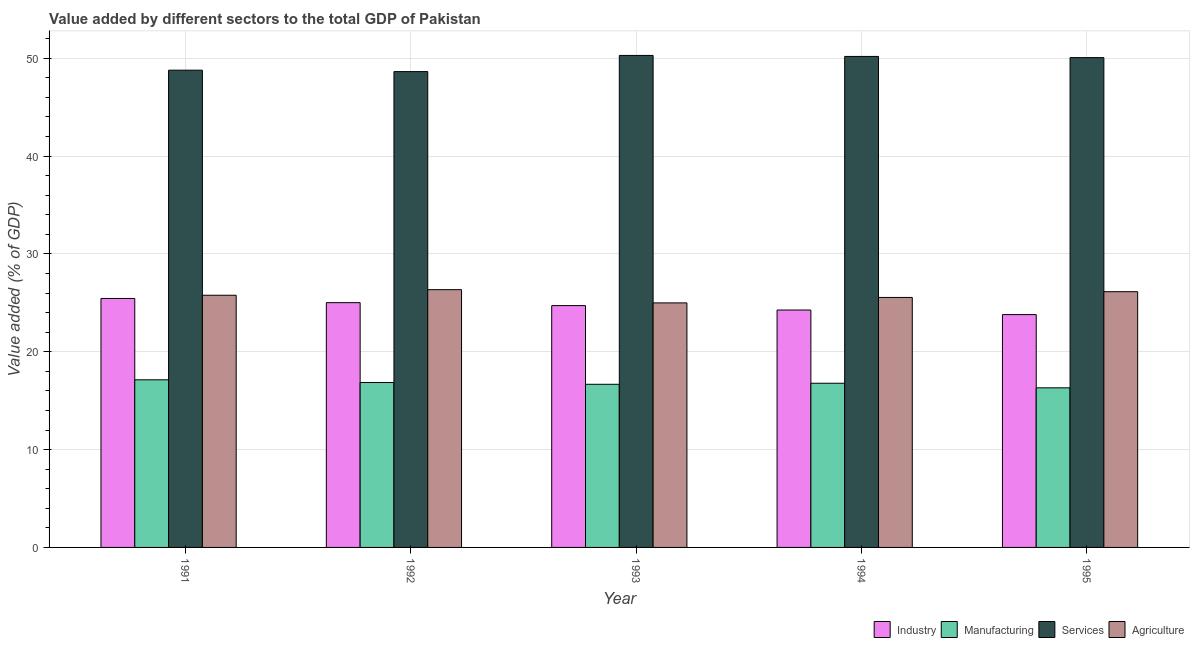How many different coloured bars are there?
Keep it short and to the point. 4. Are the number of bars per tick equal to the number of legend labels?
Provide a short and direct response. Yes. How many bars are there on the 2nd tick from the left?
Ensure brevity in your answer.  4. What is the value added by manufacturing sector in 1992?
Offer a very short reply. 16.86. Across all years, what is the maximum value added by services sector?
Offer a very short reply. 50.29. Across all years, what is the minimum value added by agricultural sector?
Your response must be concise. 24.99. In which year was the value added by industrial sector maximum?
Your answer should be very brief. 1991. In which year was the value added by services sector minimum?
Offer a very short reply. 1992. What is the total value added by services sector in the graph?
Make the answer very short. 247.95. What is the difference between the value added by agricultural sector in 1993 and that in 1994?
Offer a very short reply. -0.56. What is the difference between the value added by services sector in 1992 and the value added by industrial sector in 1993?
Make the answer very short. -1.65. What is the average value added by industrial sector per year?
Provide a short and direct response. 24.65. In the year 1991, what is the difference between the value added by services sector and value added by agricultural sector?
Make the answer very short. 0. What is the ratio of the value added by industrial sector in 1992 to that in 1994?
Provide a short and direct response. 1.03. Is the value added by agricultural sector in 1991 less than that in 1995?
Make the answer very short. Yes. Is the difference between the value added by agricultural sector in 1992 and 1994 greater than the difference between the value added by industrial sector in 1992 and 1994?
Make the answer very short. No. What is the difference between the highest and the second highest value added by agricultural sector?
Make the answer very short. 0.21. What is the difference between the highest and the lowest value added by manufacturing sector?
Provide a succinct answer. 0.82. In how many years, is the value added by services sector greater than the average value added by services sector taken over all years?
Provide a succinct answer. 3. Is it the case that in every year, the sum of the value added by agricultural sector and value added by services sector is greater than the sum of value added by industrial sector and value added by manufacturing sector?
Provide a short and direct response. No. What does the 4th bar from the left in 1992 represents?
Your answer should be compact. Agriculture. What does the 2nd bar from the right in 1991 represents?
Your response must be concise. Services. Is it the case that in every year, the sum of the value added by industrial sector and value added by manufacturing sector is greater than the value added by services sector?
Give a very brief answer. No. Are all the bars in the graph horizontal?
Your answer should be very brief. No. How many years are there in the graph?
Provide a short and direct response. 5. Does the graph contain any zero values?
Provide a short and direct response. No. Where does the legend appear in the graph?
Ensure brevity in your answer.  Bottom right. What is the title of the graph?
Provide a short and direct response. Value added by different sectors to the total GDP of Pakistan. What is the label or title of the Y-axis?
Provide a short and direct response. Value added (% of GDP). What is the Value added (% of GDP) in Industry in 1991?
Keep it short and to the point. 25.45. What is the Value added (% of GDP) in Manufacturing in 1991?
Make the answer very short. 17.13. What is the Value added (% of GDP) of Services in 1991?
Offer a terse response. 48.78. What is the Value added (% of GDP) of Agriculture in 1991?
Keep it short and to the point. 25.77. What is the Value added (% of GDP) of Industry in 1992?
Provide a succinct answer. 25.02. What is the Value added (% of GDP) in Manufacturing in 1992?
Offer a very short reply. 16.86. What is the Value added (% of GDP) in Services in 1992?
Offer a terse response. 48.63. What is the Value added (% of GDP) of Agriculture in 1992?
Your response must be concise. 26.35. What is the Value added (% of GDP) in Industry in 1993?
Offer a very short reply. 24.72. What is the Value added (% of GDP) of Manufacturing in 1993?
Make the answer very short. 16.67. What is the Value added (% of GDP) in Services in 1993?
Give a very brief answer. 50.29. What is the Value added (% of GDP) of Agriculture in 1993?
Offer a very short reply. 24.99. What is the Value added (% of GDP) in Industry in 1994?
Your response must be concise. 24.26. What is the Value added (% of GDP) in Manufacturing in 1994?
Keep it short and to the point. 16.78. What is the Value added (% of GDP) in Services in 1994?
Give a very brief answer. 50.19. What is the Value added (% of GDP) in Agriculture in 1994?
Offer a very short reply. 25.55. What is the Value added (% of GDP) of Industry in 1995?
Your answer should be compact. 23.8. What is the Value added (% of GDP) of Manufacturing in 1995?
Make the answer very short. 16.31. What is the Value added (% of GDP) of Services in 1995?
Offer a terse response. 50.06. What is the Value added (% of GDP) of Agriculture in 1995?
Provide a short and direct response. 26.14. Across all years, what is the maximum Value added (% of GDP) in Industry?
Provide a succinct answer. 25.45. Across all years, what is the maximum Value added (% of GDP) in Manufacturing?
Make the answer very short. 17.13. Across all years, what is the maximum Value added (% of GDP) in Services?
Keep it short and to the point. 50.29. Across all years, what is the maximum Value added (% of GDP) of Agriculture?
Offer a terse response. 26.35. Across all years, what is the minimum Value added (% of GDP) of Industry?
Make the answer very short. 23.8. Across all years, what is the minimum Value added (% of GDP) in Manufacturing?
Ensure brevity in your answer.  16.31. Across all years, what is the minimum Value added (% of GDP) of Services?
Make the answer very short. 48.63. Across all years, what is the minimum Value added (% of GDP) in Agriculture?
Your response must be concise. 24.99. What is the total Value added (% of GDP) of Industry in the graph?
Keep it short and to the point. 123.24. What is the total Value added (% of GDP) in Manufacturing in the graph?
Give a very brief answer. 83.76. What is the total Value added (% of GDP) in Services in the graph?
Keep it short and to the point. 247.95. What is the total Value added (% of GDP) of Agriculture in the graph?
Make the answer very short. 128.8. What is the difference between the Value added (% of GDP) of Industry in 1991 and that in 1992?
Your answer should be compact. 0.43. What is the difference between the Value added (% of GDP) of Manufacturing in 1991 and that in 1992?
Provide a short and direct response. 0.28. What is the difference between the Value added (% of GDP) of Services in 1991 and that in 1992?
Your answer should be compact. 0.14. What is the difference between the Value added (% of GDP) of Agriculture in 1991 and that in 1992?
Keep it short and to the point. -0.57. What is the difference between the Value added (% of GDP) in Industry in 1991 and that in 1993?
Give a very brief answer. 0.73. What is the difference between the Value added (% of GDP) in Manufacturing in 1991 and that in 1993?
Your response must be concise. 0.46. What is the difference between the Value added (% of GDP) in Services in 1991 and that in 1993?
Your answer should be very brief. -1.51. What is the difference between the Value added (% of GDP) of Agriculture in 1991 and that in 1993?
Offer a terse response. 0.78. What is the difference between the Value added (% of GDP) in Industry in 1991 and that in 1994?
Your answer should be compact. 1.18. What is the difference between the Value added (% of GDP) in Manufacturing in 1991 and that in 1994?
Your answer should be compact. 0.35. What is the difference between the Value added (% of GDP) in Services in 1991 and that in 1994?
Your answer should be compact. -1.41. What is the difference between the Value added (% of GDP) in Agriculture in 1991 and that in 1994?
Provide a succinct answer. 0.22. What is the difference between the Value added (% of GDP) of Industry in 1991 and that in 1995?
Provide a succinct answer. 1.65. What is the difference between the Value added (% of GDP) of Manufacturing in 1991 and that in 1995?
Your response must be concise. 0.82. What is the difference between the Value added (% of GDP) of Services in 1991 and that in 1995?
Make the answer very short. -1.28. What is the difference between the Value added (% of GDP) of Agriculture in 1991 and that in 1995?
Provide a succinct answer. -0.36. What is the difference between the Value added (% of GDP) in Industry in 1992 and that in 1993?
Your answer should be compact. 0.3. What is the difference between the Value added (% of GDP) in Manufacturing in 1992 and that in 1993?
Provide a succinct answer. 0.18. What is the difference between the Value added (% of GDP) of Services in 1992 and that in 1993?
Keep it short and to the point. -1.65. What is the difference between the Value added (% of GDP) in Agriculture in 1992 and that in 1993?
Your response must be concise. 1.35. What is the difference between the Value added (% of GDP) of Industry in 1992 and that in 1994?
Provide a short and direct response. 0.75. What is the difference between the Value added (% of GDP) of Manufacturing in 1992 and that in 1994?
Ensure brevity in your answer.  0.07. What is the difference between the Value added (% of GDP) in Services in 1992 and that in 1994?
Provide a succinct answer. -1.55. What is the difference between the Value added (% of GDP) of Agriculture in 1992 and that in 1994?
Make the answer very short. 0.8. What is the difference between the Value added (% of GDP) of Industry in 1992 and that in 1995?
Keep it short and to the point. 1.22. What is the difference between the Value added (% of GDP) in Manufacturing in 1992 and that in 1995?
Keep it short and to the point. 0.54. What is the difference between the Value added (% of GDP) in Services in 1992 and that in 1995?
Offer a very short reply. -1.43. What is the difference between the Value added (% of GDP) in Agriculture in 1992 and that in 1995?
Ensure brevity in your answer.  0.21. What is the difference between the Value added (% of GDP) in Industry in 1993 and that in 1994?
Provide a short and direct response. 0.45. What is the difference between the Value added (% of GDP) in Manufacturing in 1993 and that in 1994?
Keep it short and to the point. -0.11. What is the difference between the Value added (% of GDP) in Services in 1993 and that in 1994?
Provide a succinct answer. 0.1. What is the difference between the Value added (% of GDP) of Agriculture in 1993 and that in 1994?
Your answer should be very brief. -0.56. What is the difference between the Value added (% of GDP) of Industry in 1993 and that in 1995?
Ensure brevity in your answer.  0.92. What is the difference between the Value added (% of GDP) of Manufacturing in 1993 and that in 1995?
Offer a terse response. 0.36. What is the difference between the Value added (% of GDP) in Services in 1993 and that in 1995?
Make the answer very short. 0.22. What is the difference between the Value added (% of GDP) in Agriculture in 1993 and that in 1995?
Your response must be concise. -1.14. What is the difference between the Value added (% of GDP) of Industry in 1994 and that in 1995?
Offer a very short reply. 0.47. What is the difference between the Value added (% of GDP) in Manufacturing in 1994 and that in 1995?
Give a very brief answer. 0.47. What is the difference between the Value added (% of GDP) of Services in 1994 and that in 1995?
Provide a succinct answer. 0.12. What is the difference between the Value added (% of GDP) in Agriculture in 1994 and that in 1995?
Make the answer very short. -0.59. What is the difference between the Value added (% of GDP) of Industry in 1991 and the Value added (% of GDP) of Manufacturing in 1992?
Your answer should be very brief. 8.59. What is the difference between the Value added (% of GDP) of Industry in 1991 and the Value added (% of GDP) of Services in 1992?
Keep it short and to the point. -23.19. What is the difference between the Value added (% of GDP) in Industry in 1991 and the Value added (% of GDP) in Agriculture in 1992?
Give a very brief answer. -0.9. What is the difference between the Value added (% of GDP) in Manufacturing in 1991 and the Value added (% of GDP) in Services in 1992?
Offer a very short reply. -31.5. What is the difference between the Value added (% of GDP) of Manufacturing in 1991 and the Value added (% of GDP) of Agriculture in 1992?
Offer a very short reply. -9.21. What is the difference between the Value added (% of GDP) in Services in 1991 and the Value added (% of GDP) in Agriculture in 1992?
Your answer should be compact. 22.43. What is the difference between the Value added (% of GDP) of Industry in 1991 and the Value added (% of GDP) of Manufacturing in 1993?
Offer a terse response. 8.77. What is the difference between the Value added (% of GDP) of Industry in 1991 and the Value added (% of GDP) of Services in 1993?
Your answer should be compact. -24.84. What is the difference between the Value added (% of GDP) in Industry in 1991 and the Value added (% of GDP) in Agriculture in 1993?
Keep it short and to the point. 0.45. What is the difference between the Value added (% of GDP) of Manufacturing in 1991 and the Value added (% of GDP) of Services in 1993?
Offer a terse response. -33.16. What is the difference between the Value added (% of GDP) in Manufacturing in 1991 and the Value added (% of GDP) in Agriculture in 1993?
Your response must be concise. -7.86. What is the difference between the Value added (% of GDP) in Services in 1991 and the Value added (% of GDP) in Agriculture in 1993?
Make the answer very short. 23.79. What is the difference between the Value added (% of GDP) of Industry in 1991 and the Value added (% of GDP) of Manufacturing in 1994?
Offer a terse response. 8.66. What is the difference between the Value added (% of GDP) of Industry in 1991 and the Value added (% of GDP) of Services in 1994?
Make the answer very short. -24.74. What is the difference between the Value added (% of GDP) in Industry in 1991 and the Value added (% of GDP) in Agriculture in 1994?
Keep it short and to the point. -0.1. What is the difference between the Value added (% of GDP) of Manufacturing in 1991 and the Value added (% of GDP) of Services in 1994?
Keep it short and to the point. -33.05. What is the difference between the Value added (% of GDP) in Manufacturing in 1991 and the Value added (% of GDP) in Agriculture in 1994?
Make the answer very short. -8.42. What is the difference between the Value added (% of GDP) in Services in 1991 and the Value added (% of GDP) in Agriculture in 1994?
Make the answer very short. 23.23. What is the difference between the Value added (% of GDP) in Industry in 1991 and the Value added (% of GDP) in Manufacturing in 1995?
Offer a terse response. 9.13. What is the difference between the Value added (% of GDP) of Industry in 1991 and the Value added (% of GDP) of Services in 1995?
Give a very brief answer. -24.62. What is the difference between the Value added (% of GDP) of Industry in 1991 and the Value added (% of GDP) of Agriculture in 1995?
Provide a succinct answer. -0.69. What is the difference between the Value added (% of GDP) of Manufacturing in 1991 and the Value added (% of GDP) of Services in 1995?
Your answer should be very brief. -32.93. What is the difference between the Value added (% of GDP) in Manufacturing in 1991 and the Value added (% of GDP) in Agriculture in 1995?
Your response must be concise. -9.01. What is the difference between the Value added (% of GDP) of Services in 1991 and the Value added (% of GDP) of Agriculture in 1995?
Your answer should be compact. 22.64. What is the difference between the Value added (% of GDP) in Industry in 1992 and the Value added (% of GDP) in Manufacturing in 1993?
Make the answer very short. 8.34. What is the difference between the Value added (% of GDP) in Industry in 1992 and the Value added (% of GDP) in Services in 1993?
Offer a very short reply. -25.27. What is the difference between the Value added (% of GDP) of Industry in 1992 and the Value added (% of GDP) of Agriculture in 1993?
Make the answer very short. 0.02. What is the difference between the Value added (% of GDP) in Manufacturing in 1992 and the Value added (% of GDP) in Services in 1993?
Make the answer very short. -33.43. What is the difference between the Value added (% of GDP) of Manufacturing in 1992 and the Value added (% of GDP) of Agriculture in 1993?
Your response must be concise. -8.14. What is the difference between the Value added (% of GDP) of Services in 1992 and the Value added (% of GDP) of Agriculture in 1993?
Provide a succinct answer. 23.64. What is the difference between the Value added (% of GDP) in Industry in 1992 and the Value added (% of GDP) in Manufacturing in 1994?
Your response must be concise. 8.24. What is the difference between the Value added (% of GDP) in Industry in 1992 and the Value added (% of GDP) in Services in 1994?
Make the answer very short. -25.17. What is the difference between the Value added (% of GDP) in Industry in 1992 and the Value added (% of GDP) in Agriculture in 1994?
Provide a succinct answer. -0.53. What is the difference between the Value added (% of GDP) of Manufacturing in 1992 and the Value added (% of GDP) of Services in 1994?
Provide a succinct answer. -33.33. What is the difference between the Value added (% of GDP) in Manufacturing in 1992 and the Value added (% of GDP) in Agriculture in 1994?
Your answer should be very brief. -8.69. What is the difference between the Value added (% of GDP) of Services in 1992 and the Value added (% of GDP) of Agriculture in 1994?
Your answer should be very brief. 23.08. What is the difference between the Value added (% of GDP) of Industry in 1992 and the Value added (% of GDP) of Manufacturing in 1995?
Provide a succinct answer. 8.7. What is the difference between the Value added (% of GDP) in Industry in 1992 and the Value added (% of GDP) in Services in 1995?
Provide a short and direct response. -25.05. What is the difference between the Value added (% of GDP) of Industry in 1992 and the Value added (% of GDP) of Agriculture in 1995?
Your answer should be very brief. -1.12. What is the difference between the Value added (% of GDP) in Manufacturing in 1992 and the Value added (% of GDP) in Services in 1995?
Give a very brief answer. -33.21. What is the difference between the Value added (% of GDP) of Manufacturing in 1992 and the Value added (% of GDP) of Agriculture in 1995?
Provide a succinct answer. -9.28. What is the difference between the Value added (% of GDP) of Services in 1992 and the Value added (% of GDP) of Agriculture in 1995?
Your answer should be compact. 22.5. What is the difference between the Value added (% of GDP) of Industry in 1993 and the Value added (% of GDP) of Manufacturing in 1994?
Your response must be concise. 7.94. What is the difference between the Value added (% of GDP) of Industry in 1993 and the Value added (% of GDP) of Services in 1994?
Offer a very short reply. -25.47. What is the difference between the Value added (% of GDP) in Industry in 1993 and the Value added (% of GDP) in Agriculture in 1994?
Give a very brief answer. -0.83. What is the difference between the Value added (% of GDP) of Manufacturing in 1993 and the Value added (% of GDP) of Services in 1994?
Ensure brevity in your answer.  -33.51. What is the difference between the Value added (% of GDP) of Manufacturing in 1993 and the Value added (% of GDP) of Agriculture in 1994?
Ensure brevity in your answer.  -8.88. What is the difference between the Value added (% of GDP) in Services in 1993 and the Value added (% of GDP) in Agriculture in 1994?
Your answer should be very brief. 24.74. What is the difference between the Value added (% of GDP) in Industry in 1993 and the Value added (% of GDP) in Manufacturing in 1995?
Give a very brief answer. 8.4. What is the difference between the Value added (% of GDP) of Industry in 1993 and the Value added (% of GDP) of Services in 1995?
Provide a short and direct response. -25.35. What is the difference between the Value added (% of GDP) of Industry in 1993 and the Value added (% of GDP) of Agriculture in 1995?
Offer a terse response. -1.42. What is the difference between the Value added (% of GDP) of Manufacturing in 1993 and the Value added (% of GDP) of Services in 1995?
Ensure brevity in your answer.  -33.39. What is the difference between the Value added (% of GDP) in Manufacturing in 1993 and the Value added (% of GDP) in Agriculture in 1995?
Your answer should be compact. -9.46. What is the difference between the Value added (% of GDP) in Services in 1993 and the Value added (% of GDP) in Agriculture in 1995?
Your response must be concise. 24.15. What is the difference between the Value added (% of GDP) in Industry in 1994 and the Value added (% of GDP) in Manufacturing in 1995?
Your answer should be compact. 7.95. What is the difference between the Value added (% of GDP) in Industry in 1994 and the Value added (% of GDP) in Services in 1995?
Provide a succinct answer. -25.8. What is the difference between the Value added (% of GDP) in Industry in 1994 and the Value added (% of GDP) in Agriculture in 1995?
Offer a terse response. -1.87. What is the difference between the Value added (% of GDP) in Manufacturing in 1994 and the Value added (% of GDP) in Services in 1995?
Offer a terse response. -33.28. What is the difference between the Value added (% of GDP) in Manufacturing in 1994 and the Value added (% of GDP) in Agriculture in 1995?
Offer a very short reply. -9.36. What is the difference between the Value added (% of GDP) in Services in 1994 and the Value added (% of GDP) in Agriculture in 1995?
Keep it short and to the point. 24.05. What is the average Value added (% of GDP) of Industry per year?
Provide a succinct answer. 24.65. What is the average Value added (% of GDP) of Manufacturing per year?
Ensure brevity in your answer.  16.75. What is the average Value added (% of GDP) of Services per year?
Offer a very short reply. 49.59. What is the average Value added (% of GDP) of Agriculture per year?
Your answer should be very brief. 25.76. In the year 1991, what is the difference between the Value added (% of GDP) of Industry and Value added (% of GDP) of Manufacturing?
Your response must be concise. 8.31. In the year 1991, what is the difference between the Value added (% of GDP) of Industry and Value added (% of GDP) of Services?
Keep it short and to the point. -23.33. In the year 1991, what is the difference between the Value added (% of GDP) in Industry and Value added (% of GDP) in Agriculture?
Give a very brief answer. -0.33. In the year 1991, what is the difference between the Value added (% of GDP) of Manufacturing and Value added (% of GDP) of Services?
Your response must be concise. -31.65. In the year 1991, what is the difference between the Value added (% of GDP) in Manufacturing and Value added (% of GDP) in Agriculture?
Provide a short and direct response. -8.64. In the year 1991, what is the difference between the Value added (% of GDP) of Services and Value added (% of GDP) of Agriculture?
Your answer should be compact. 23.01. In the year 1992, what is the difference between the Value added (% of GDP) in Industry and Value added (% of GDP) in Manufacturing?
Keep it short and to the point. 8.16. In the year 1992, what is the difference between the Value added (% of GDP) in Industry and Value added (% of GDP) in Services?
Give a very brief answer. -23.62. In the year 1992, what is the difference between the Value added (% of GDP) of Industry and Value added (% of GDP) of Agriculture?
Provide a short and direct response. -1.33. In the year 1992, what is the difference between the Value added (% of GDP) of Manufacturing and Value added (% of GDP) of Services?
Your response must be concise. -31.78. In the year 1992, what is the difference between the Value added (% of GDP) of Manufacturing and Value added (% of GDP) of Agriculture?
Ensure brevity in your answer.  -9.49. In the year 1992, what is the difference between the Value added (% of GDP) in Services and Value added (% of GDP) in Agriculture?
Keep it short and to the point. 22.29. In the year 1993, what is the difference between the Value added (% of GDP) of Industry and Value added (% of GDP) of Manufacturing?
Make the answer very short. 8.04. In the year 1993, what is the difference between the Value added (% of GDP) of Industry and Value added (% of GDP) of Services?
Provide a short and direct response. -25.57. In the year 1993, what is the difference between the Value added (% of GDP) of Industry and Value added (% of GDP) of Agriculture?
Your response must be concise. -0.28. In the year 1993, what is the difference between the Value added (% of GDP) in Manufacturing and Value added (% of GDP) in Services?
Provide a succinct answer. -33.61. In the year 1993, what is the difference between the Value added (% of GDP) in Manufacturing and Value added (% of GDP) in Agriculture?
Offer a terse response. -8.32. In the year 1993, what is the difference between the Value added (% of GDP) of Services and Value added (% of GDP) of Agriculture?
Your response must be concise. 25.29. In the year 1994, what is the difference between the Value added (% of GDP) in Industry and Value added (% of GDP) in Manufacturing?
Provide a succinct answer. 7.48. In the year 1994, what is the difference between the Value added (% of GDP) of Industry and Value added (% of GDP) of Services?
Give a very brief answer. -25.92. In the year 1994, what is the difference between the Value added (% of GDP) of Industry and Value added (% of GDP) of Agriculture?
Ensure brevity in your answer.  -1.29. In the year 1994, what is the difference between the Value added (% of GDP) in Manufacturing and Value added (% of GDP) in Services?
Ensure brevity in your answer.  -33.4. In the year 1994, what is the difference between the Value added (% of GDP) in Manufacturing and Value added (% of GDP) in Agriculture?
Offer a very short reply. -8.77. In the year 1994, what is the difference between the Value added (% of GDP) of Services and Value added (% of GDP) of Agriculture?
Make the answer very short. 24.63. In the year 1995, what is the difference between the Value added (% of GDP) in Industry and Value added (% of GDP) in Manufacturing?
Keep it short and to the point. 7.48. In the year 1995, what is the difference between the Value added (% of GDP) of Industry and Value added (% of GDP) of Services?
Offer a terse response. -26.27. In the year 1995, what is the difference between the Value added (% of GDP) of Industry and Value added (% of GDP) of Agriculture?
Provide a short and direct response. -2.34. In the year 1995, what is the difference between the Value added (% of GDP) of Manufacturing and Value added (% of GDP) of Services?
Your answer should be very brief. -33.75. In the year 1995, what is the difference between the Value added (% of GDP) in Manufacturing and Value added (% of GDP) in Agriculture?
Make the answer very short. -9.83. In the year 1995, what is the difference between the Value added (% of GDP) of Services and Value added (% of GDP) of Agriculture?
Offer a terse response. 23.93. What is the ratio of the Value added (% of GDP) of Industry in 1991 to that in 1992?
Ensure brevity in your answer.  1.02. What is the ratio of the Value added (% of GDP) of Manufacturing in 1991 to that in 1992?
Offer a very short reply. 1.02. What is the ratio of the Value added (% of GDP) in Agriculture in 1991 to that in 1992?
Give a very brief answer. 0.98. What is the ratio of the Value added (% of GDP) of Industry in 1991 to that in 1993?
Offer a very short reply. 1.03. What is the ratio of the Value added (% of GDP) in Manufacturing in 1991 to that in 1993?
Give a very brief answer. 1.03. What is the ratio of the Value added (% of GDP) of Services in 1991 to that in 1993?
Provide a short and direct response. 0.97. What is the ratio of the Value added (% of GDP) of Agriculture in 1991 to that in 1993?
Your response must be concise. 1.03. What is the ratio of the Value added (% of GDP) in Industry in 1991 to that in 1994?
Your response must be concise. 1.05. What is the ratio of the Value added (% of GDP) of Manufacturing in 1991 to that in 1994?
Give a very brief answer. 1.02. What is the ratio of the Value added (% of GDP) in Services in 1991 to that in 1994?
Your answer should be compact. 0.97. What is the ratio of the Value added (% of GDP) of Agriculture in 1991 to that in 1994?
Keep it short and to the point. 1.01. What is the ratio of the Value added (% of GDP) in Industry in 1991 to that in 1995?
Your response must be concise. 1.07. What is the ratio of the Value added (% of GDP) of Manufacturing in 1991 to that in 1995?
Provide a succinct answer. 1.05. What is the ratio of the Value added (% of GDP) in Services in 1991 to that in 1995?
Provide a short and direct response. 0.97. What is the ratio of the Value added (% of GDP) in Agriculture in 1991 to that in 1995?
Provide a short and direct response. 0.99. What is the ratio of the Value added (% of GDP) of Industry in 1992 to that in 1993?
Your response must be concise. 1.01. What is the ratio of the Value added (% of GDP) in Manufacturing in 1992 to that in 1993?
Give a very brief answer. 1.01. What is the ratio of the Value added (% of GDP) in Services in 1992 to that in 1993?
Give a very brief answer. 0.97. What is the ratio of the Value added (% of GDP) of Agriculture in 1992 to that in 1993?
Offer a very short reply. 1.05. What is the ratio of the Value added (% of GDP) in Industry in 1992 to that in 1994?
Offer a very short reply. 1.03. What is the ratio of the Value added (% of GDP) in Services in 1992 to that in 1994?
Offer a very short reply. 0.97. What is the ratio of the Value added (% of GDP) of Agriculture in 1992 to that in 1994?
Give a very brief answer. 1.03. What is the ratio of the Value added (% of GDP) of Industry in 1992 to that in 1995?
Give a very brief answer. 1.05. What is the ratio of the Value added (% of GDP) of Manufacturing in 1992 to that in 1995?
Your answer should be compact. 1.03. What is the ratio of the Value added (% of GDP) of Services in 1992 to that in 1995?
Provide a succinct answer. 0.97. What is the ratio of the Value added (% of GDP) of Agriculture in 1992 to that in 1995?
Offer a very short reply. 1.01. What is the ratio of the Value added (% of GDP) in Industry in 1993 to that in 1994?
Your answer should be very brief. 1.02. What is the ratio of the Value added (% of GDP) of Services in 1993 to that in 1994?
Offer a terse response. 1. What is the ratio of the Value added (% of GDP) of Agriculture in 1993 to that in 1994?
Offer a terse response. 0.98. What is the ratio of the Value added (% of GDP) in Industry in 1993 to that in 1995?
Offer a terse response. 1.04. What is the ratio of the Value added (% of GDP) in Manufacturing in 1993 to that in 1995?
Keep it short and to the point. 1.02. What is the ratio of the Value added (% of GDP) in Agriculture in 1993 to that in 1995?
Keep it short and to the point. 0.96. What is the ratio of the Value added (% of GDP) of Industry in 1994 to that in 1995?
Make the answer very short. 1.02. What is the ratio of the Value added (% of GDP) in Manufacturing in 1994 to that in 1995?
Your response must be concise. 1.03. What is the ratio of the Value added (% of GDP) in Services in 1994 to that in 1995?
Your answer should be very brief. 1. What is the ratio of the Value added (% of GDP) in Agriculture in 1994 to that in 1995?
Ensure brevity in your answer.  0.98. What is the difference between the highest and the second highest Value added (% of GDP) in Industry?
Keep it short and to the point. 0.43. What is the difference between the highest and the second highest Value added (% of GDP) in Manufacturing?
Offer a very short reply. 0.28. What is the difference between the highest and the second highest Value added (% of GDP) of Services?
Offer a terse response. 0.1. What is the difference between the highest and the second highest Value added (% of GDP) of Agriculture?
Your answer should be very brief. 0.21. What is the difference between the highest and the lowest Value added (% of GDP) of Industry?
Make the answer very short. 1.65. What is the difference between the highest and the lowest Value added (% of GDP) in Manufacturing?
Ensure brevity in your answer.  0.82. What is the difference between the highest and the lowest Value added (% of GDP) of Services?
Your answer should be compact. 1.65. What is the difference between the highest and the lowest Value added (% of GDP) in Agriculture?
Keep it short and to the point. 1.35. 